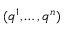<formula> <loc_0><loc_0><loc_500><loc_500>( q ^ { 1 } , \dots , q ^ { n } )</formula> 